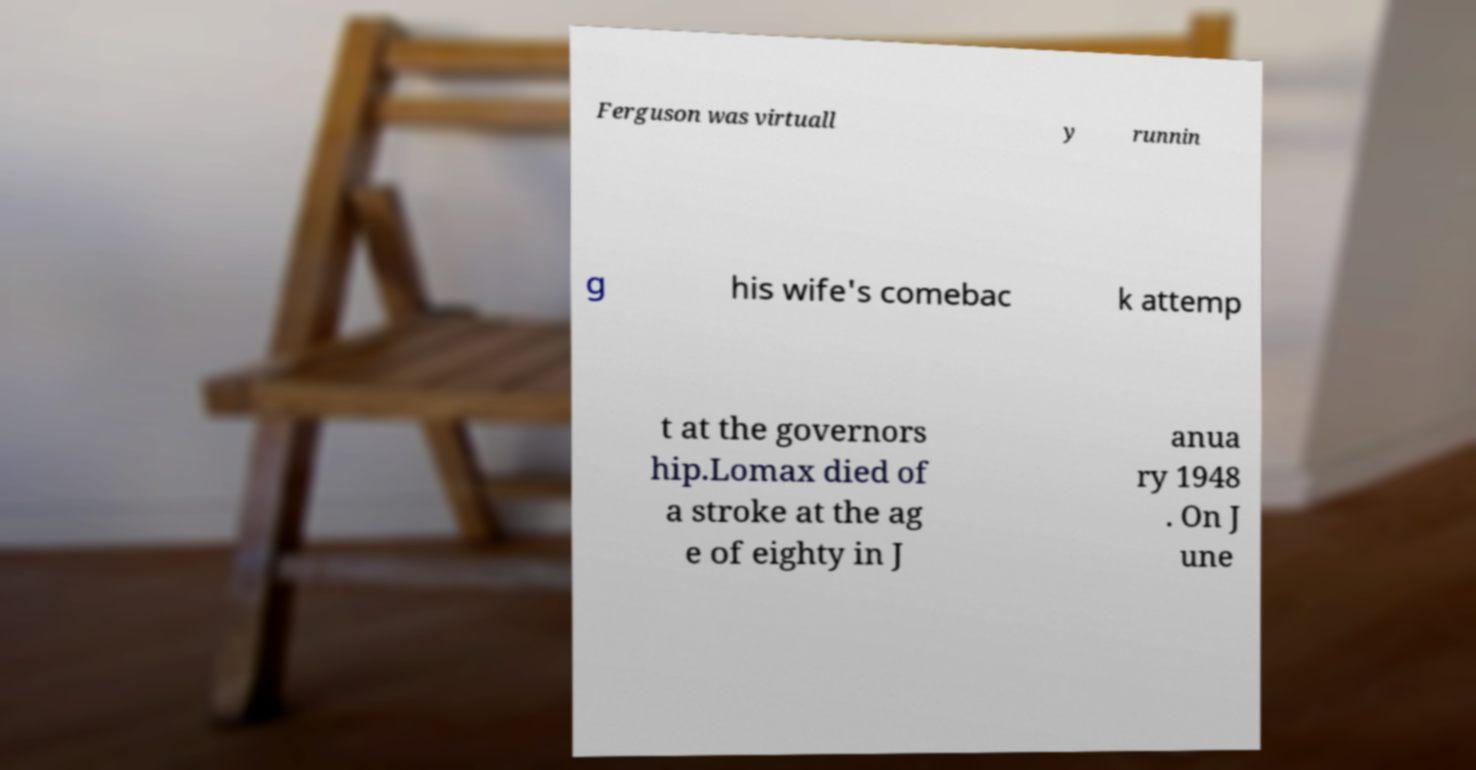Please identify and transcribe the text found in this image. Ferguson was virtuall y runnin g his wife's comebac k attemp t at the governors hip.Lomax died of a stroke at the ag e of eighty in J anua ry 1948 . On J une 